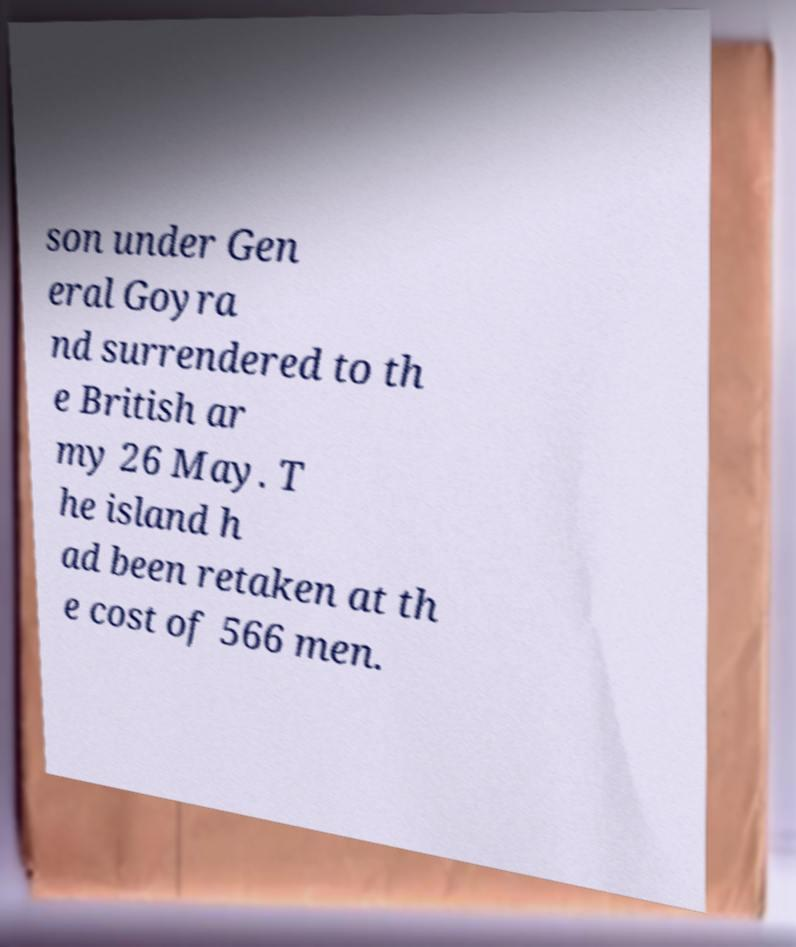Could you assist in decoding the text presented in this image and type it out clearly? son under Gen eral Goyra nd surrendered to th e British ar my 26 May. T he island h ad been retaken at th e cost of 566 men. 